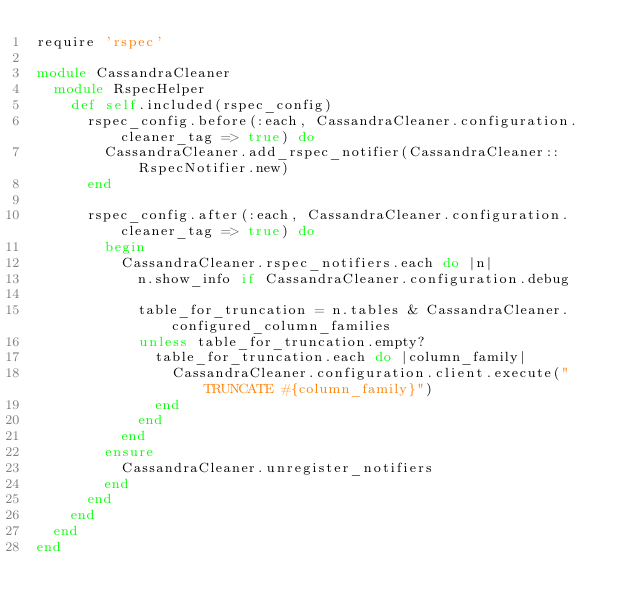<code> <loc_0><loc_0><loc_500><loc_500><_Ruby_>require 'rspec'

module CassandraCleaner
  module RspecHelper
    def self.included(rspec_config)
      rspec_config.before(:each, CassandraCleaner.configuration.cleaner_tag => true) do
        CassandraCleaner.add_rspec_notifier(CassandraCleaner::RspecNotifier.new)
      end

      rspec_config.after(:each, CassandraCleaner.configuration.cleaner_tag => true) do
        begin
          CassandraCleaner.rspec_notifiers.each do |n| 
            n.show_info if CassandraCleaner.configuration.debug
            
            table_for_truncation = n.tables & CassandraCleaner.configured_column_families
            unless table_for_truncation.empty?
              table_for_truncation.each do |column_family|
                CassandraCleaner.configuration.client.execute("TRUNCATE #{column_family}")
              end
            end
          end
        ensure
          CassandraCleaner.unregister_notifiers
        end
      end
    end
  end
end</code> 